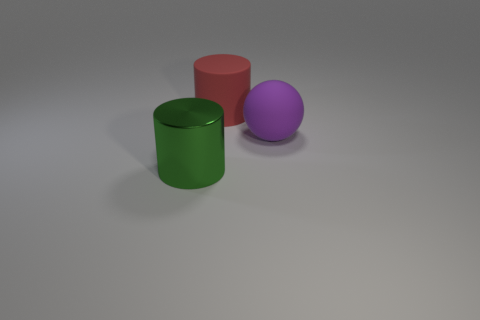Add 3 large green spheres. How many objects exist? 6 Subtract all balls. How many objects are left? 2 Subtract 0 gray spheres. How many objects are left? 3 Subtract all large cyan metallic blocks. Subtract all matte cylinders. How many objects are left? 2 Add 1 red cylinders. How many red cylinders are left? 2 Add 2 big yellow cylinders. How many big yellow cylinders exist? 2 